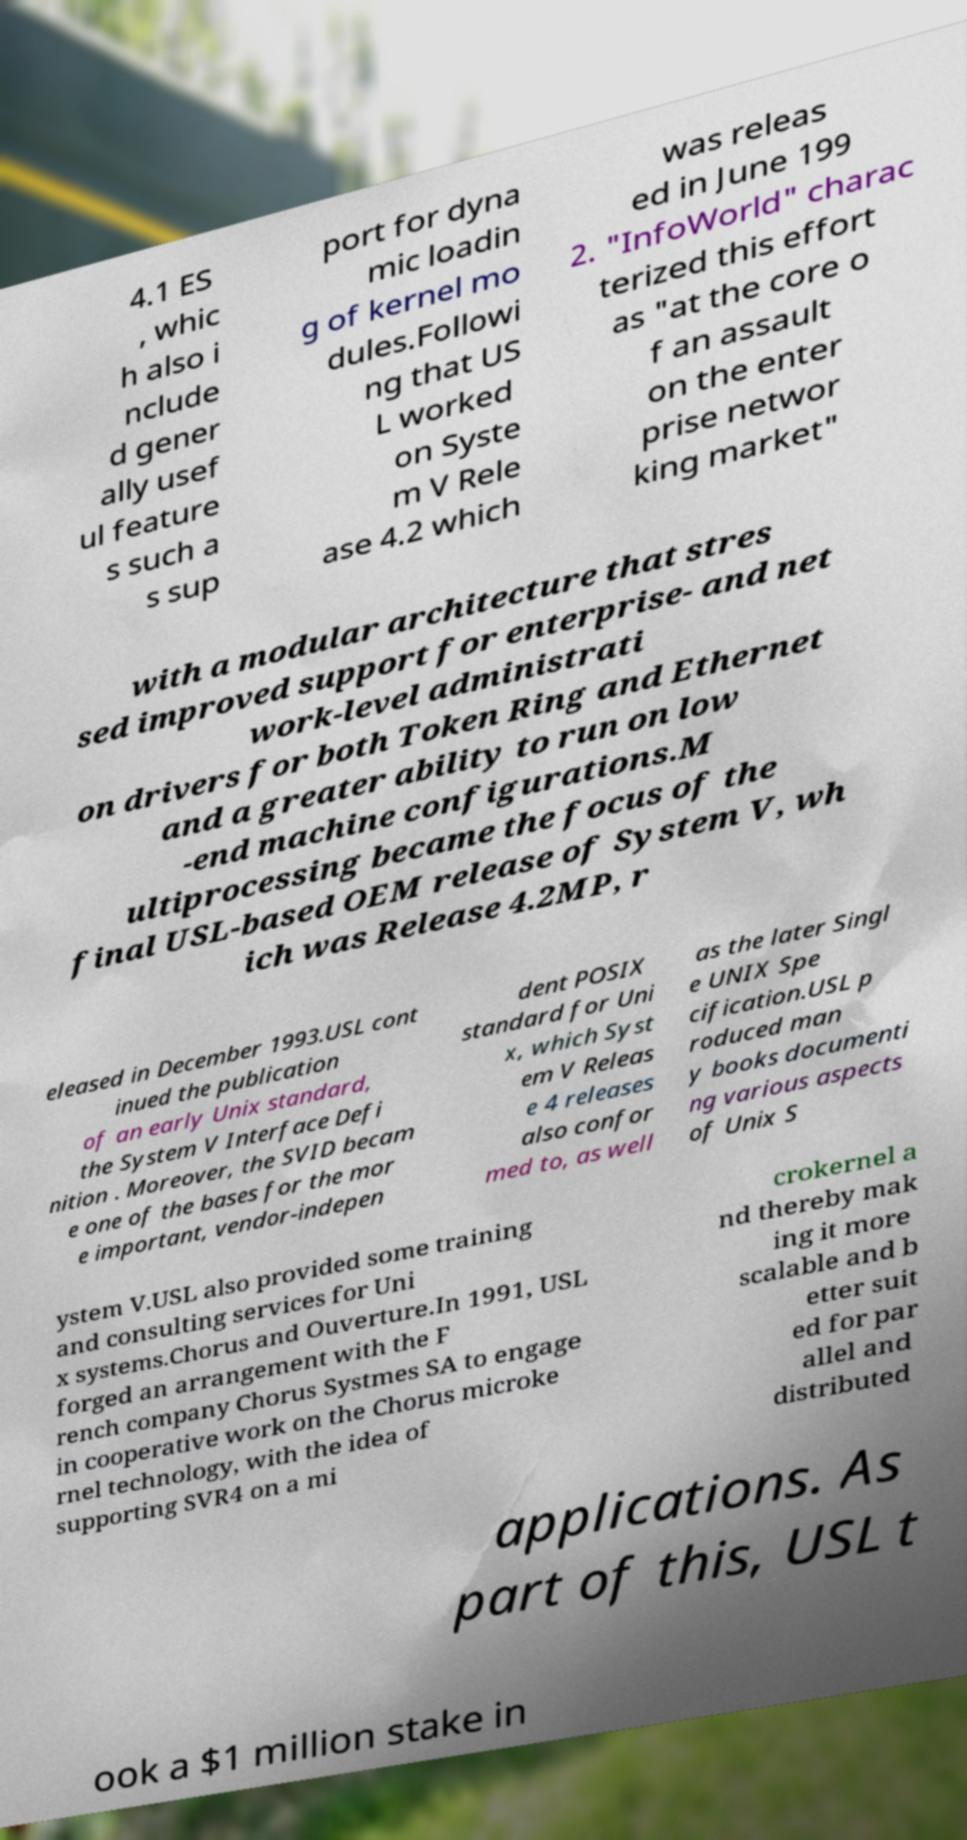There's text embedded in this image that I need extracted. Can you transcribe it verbatim? 4.1 ES , whic h also i nclude d gener ally usef ul feature s such a s sup port for dyna mic loadin g of kernel mo dules.Followi ng that US L worked on Syste m V Rele ase 4.2 which was releas ed in June 199 2. "InfoWorld" charac terized this effort as "at the core o f an assault on the enter prise networ king market" with a modular architecture that stres sed improved support for enterprise- and net work-level administrati on drivers for both Token Ring and Ethernet and a greater ability to run on low -end machine configurations.M ultiprocessing became the focus of the final USL-based OEM release of System V, wh ich was Release 4.2MP, r eleased in December 1993.USL cont inued the publication of an early Unix standard, the System V Interface Defi nition . Moreover, the SVID becam e one of the bases for the mor e important, vendor-indepen dent POSIX standard for Uni x, which Syst em V Releas e 4 releases also confor med to, as well as the later Singl e UNIX Spe cification.USL p roduced man y books documenti ng various aspects of Unix S ystem V.USL also provided some training and consulting services for Uni x systems.Chorus and Ouverture.In 1991, USL forged an arrangement with the F rench company Chorus Systmes SA to engage in cooperative work on the Chorus microke rnel technology, with the idea of supporting SVR4 on a mi crokernel a nd thereby mak ing it more scalable and b etter suit ed for par allel and distributed applications. As part of this, USL t ook a $1 million stake in 